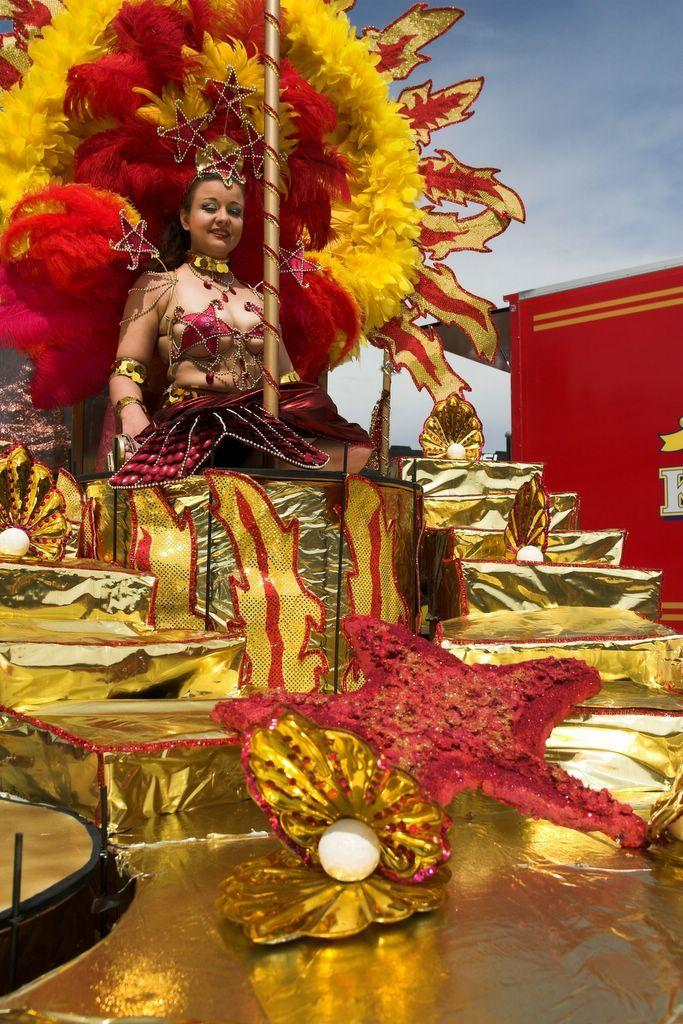What is the lady in the image wearing? The lady in the image is wearing a costume. What is the lady sitting on in the image? The lady is sitting on a palanquin. What other items can be seen in the image besides the lady and the palanquin? There are decor items and a shed with some text in the image. What is visible at the top of the image? The sky is visible at the top of the image. What type of hand can be seen playing a pipe in the image? There is no hand or pipe present in the image. What items are on the list that the lady is holding in the image? There is no list or item-holding in the image; the lady is sitting on a palanquin. 